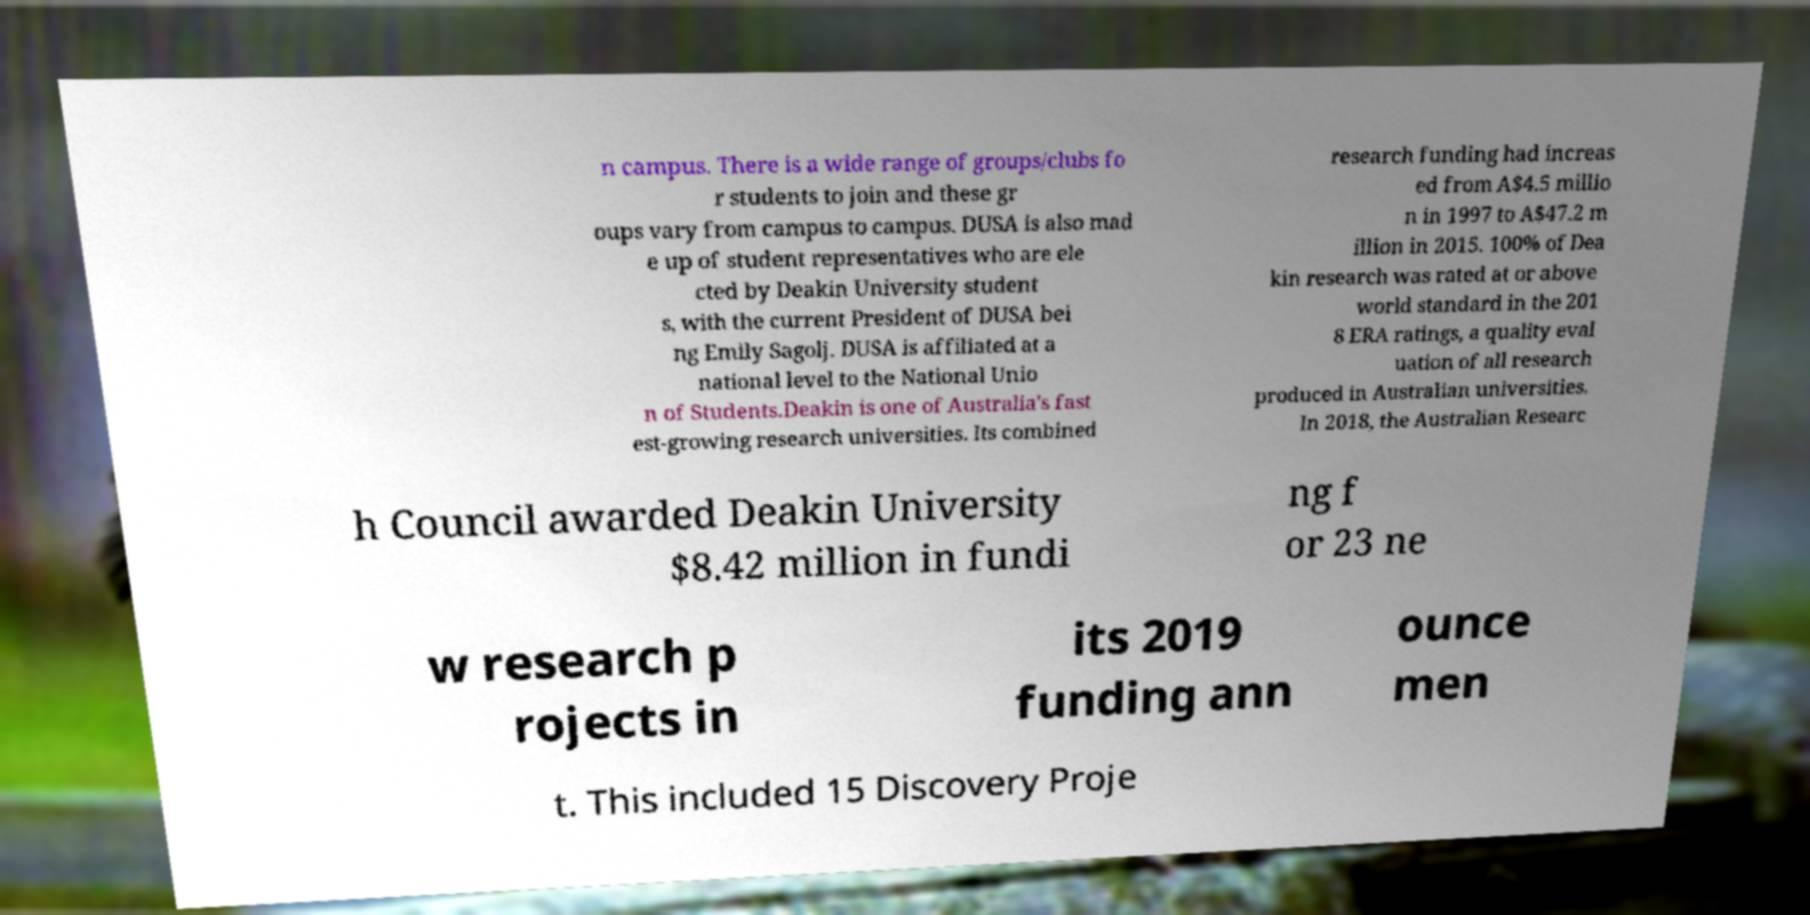Could you extract and type out the text from this image? n campus. There is a wide range of groups/clubs fo r students to join and these gr oups vary from campus to campus. DUSA is also mad e up of student representatives who are ele cted by Deakin University student s, with the current President of DUSA bei ng Emily Sagolj. DUSA is affiliated at a national level to the National Unio n of Students.Deakin is one of Australia's fast est-growing research universities. Its combined research funding had increas ed from A$4.5 millio n in 1997 to A$47.2 m illion in 2015. 100% of Dea kin research was rated at or above world standard in the 201 8 ERA ratings, a quality eval uation of all research produced in Australian universities. In 2018, the Australian Researc h Council awarded Deakin University $8.42 million in fundi ng f or 23 ne w research p rojects in its 2019 funding ann ounce men t. This included 15 Discovery Proje 